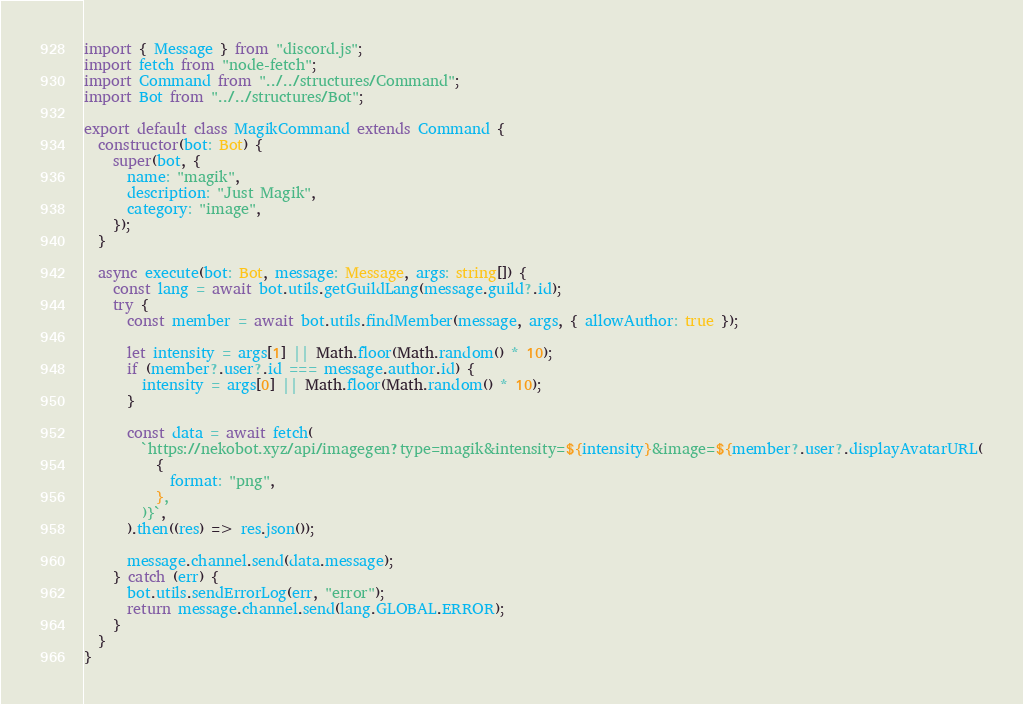<code> <loc_0><loc_0><loc_500><loc_500><_TypeScript_>import { Message } from "discord.js";
import fetch from "node-fetch";
import Command from "../../structures/Command";
import Bot from "../../structures/Bot";

export default class MagikCommand extends Command {
  constructor(bot: Bot) {
    super(bot, {
      name: "magik",
      description: "Just Magik",
      category: "image",
    });
  }

  async execute(bot: Bot, message: Message, args: string[]) {
    const lang = await bot.utils.getGuildLang(message.guild?.id);
    try {
      const member = await bot.utils.findMember(message, args, { allowAuthor: true });

      let intensity = args[1] || Math.floor(Math.random() * 10);
      if (member?.user?.id === message.author.id) {
        intensity = args[0] || Math.floor(Math.random() * 10);
      }

      const data = await fetch(
        `https://nekobot.xyz/api/imagegen?type=magik&intensity=${intensity}&image=${member?.user?.displayAvatarURL(
          {
            format: "png",
          },
        )}`,
      ).then((res) => res.json());

      message.channel.send(data.message);
    } catch (err) {
      bot.utils.sendErrorLog(err, "error");
      return message.channel.send(lang.GLOBAL.ERROR);
    }
  }
}
</code> 